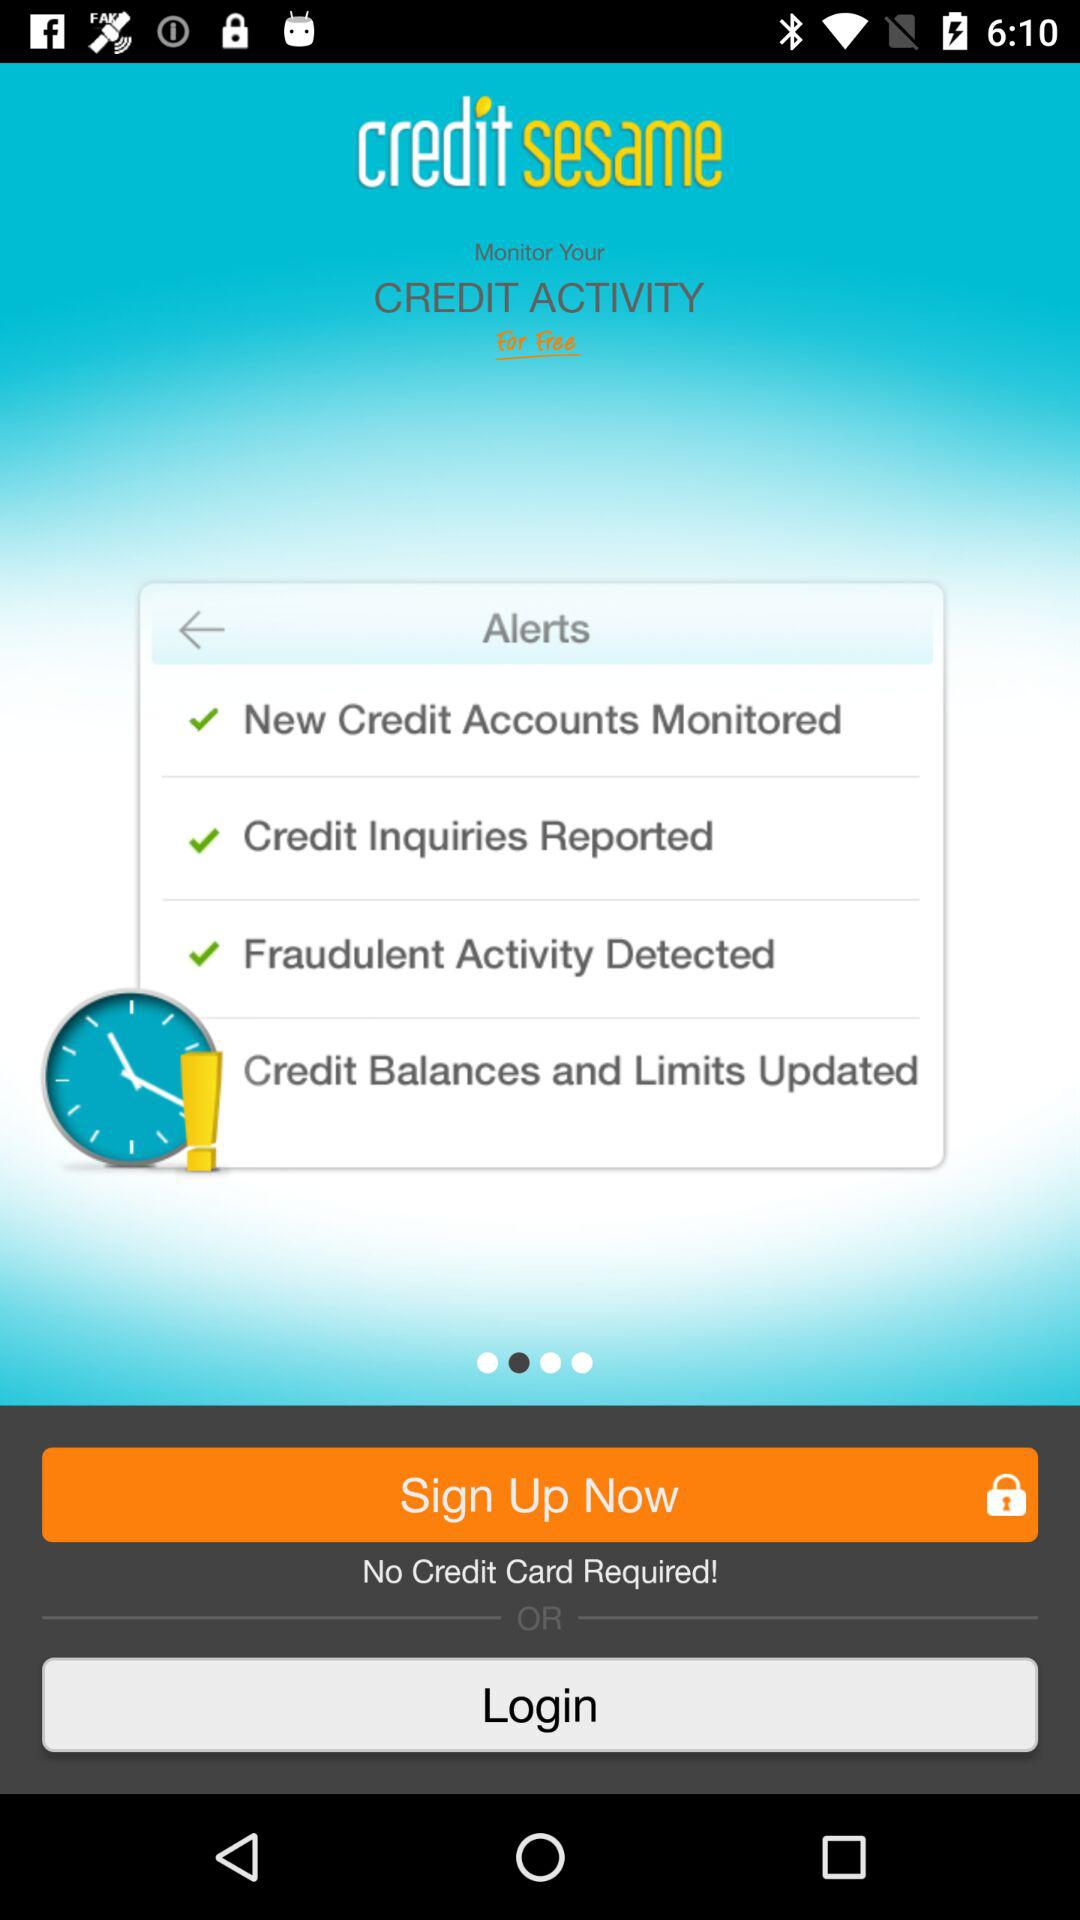Is a credit card required to sign up? A credit card is not required to sign up. 